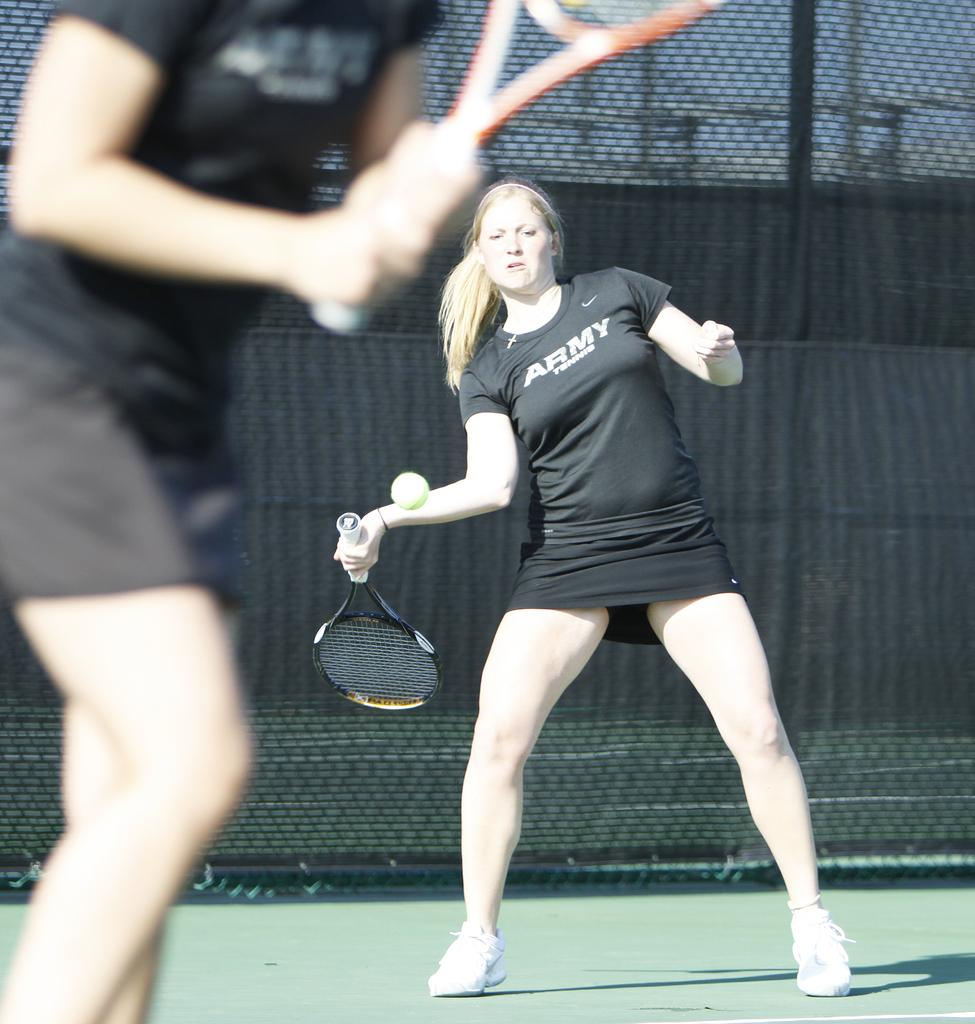How many people are in the image? There are two women in the image. What activity are the women engaged in? The women are playing tennis. What objects are the women holding in their hands? The women are holding bats in their hands. What color are the dresses the women are wearing? The women are wearing black dresses. What can be seen in the background of the image? There is a fence in the background of the image. How many apples are on the ground near the women in the image? There are no apples present in the image. What type of quiver is the woman on the left using to hold her tennis balls? There is no quiver present in the image, and the women are not using any equipment to hold tennis balls. 